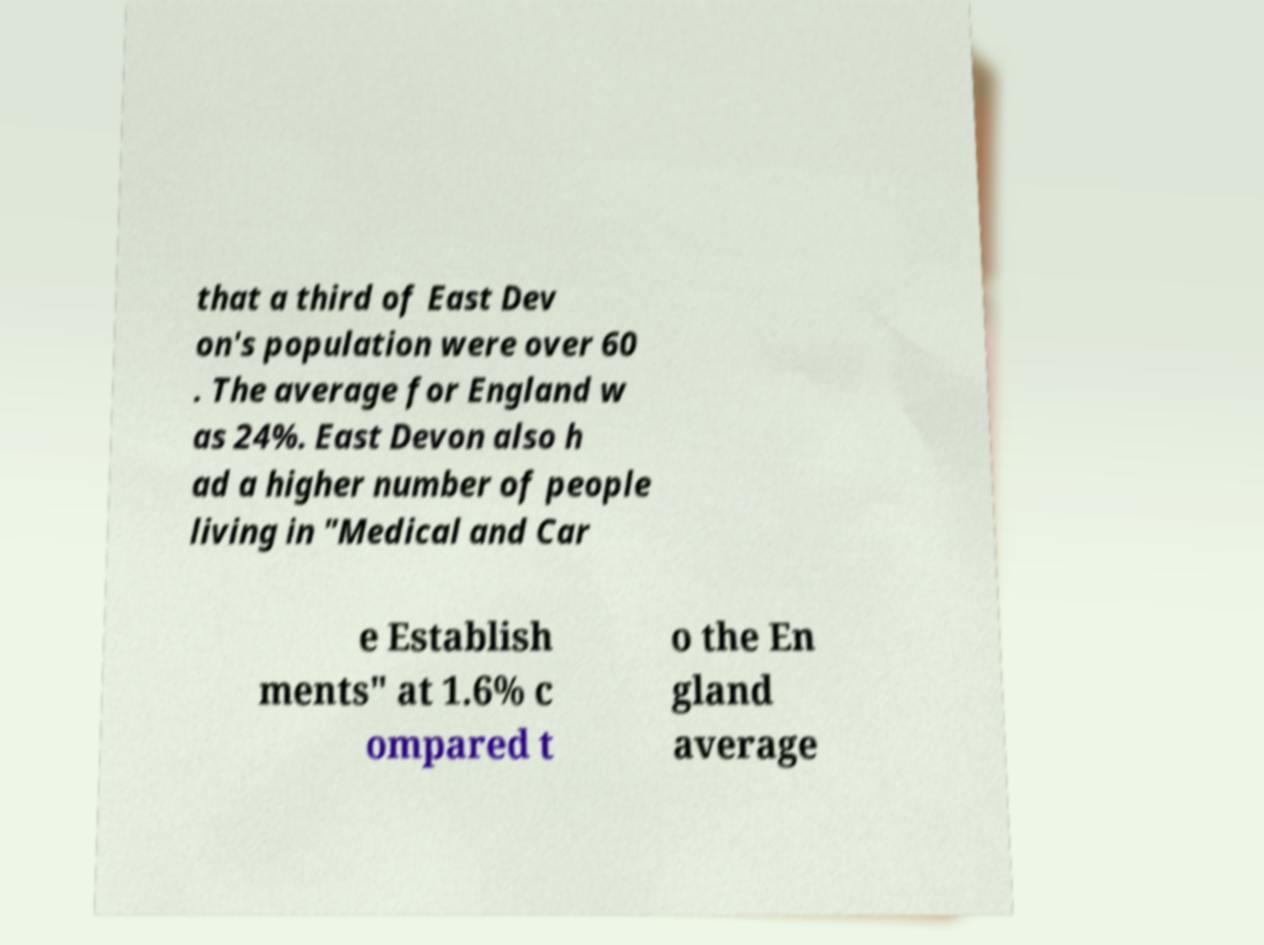Could you assist in decoding the text presented in this image and type it out clearly? that a third of East Dev on's population were over 60 . The average for England w as 24%. East Devon also h ad a higher number of people living in "Medical and Car e Establish ments" at 1.6% c ompared t o the En gland average 